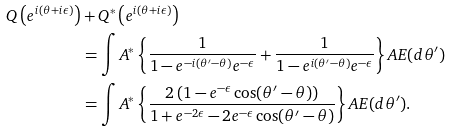Convert formula to latex. <formula><loc_0><loc_0><loc_500><loc_500>Q \left ( e ^ { i ( \theta + i \epsilon ) } \right ) & + Q ^ { * } \left ( e ^ { i ( \theta + i \epsilon ) } \right ) \\ & = \int A ^ { * } \left \{ \frac { 1 } { 1 - e ^ { - i ( \theta ^ { \prime } - \theta ) } e ^ { - \epsilon } } + \frac { 1 } { 1 - e ^ { i ( \theta ^ { \prime } - \theta ) } e ^ { - \epsilon } } \right \} A E ( d \theta ^ { \prime } ) \\ & = \int A ^ { * } \left \{ \frac { 2 \left ( 1 - e ^ { - \epsilon } \cos ( \theta ^ { \prime } - \theta ) \right ) } { 1 + e ^ { - 2 \epsilon } - 2 e ^ { - \epsilon } \cos ( \theta ^ { \prime } - \theta ) } \right \} A E ( d \theta ^ { \prime } ) \text {.}</formula> 